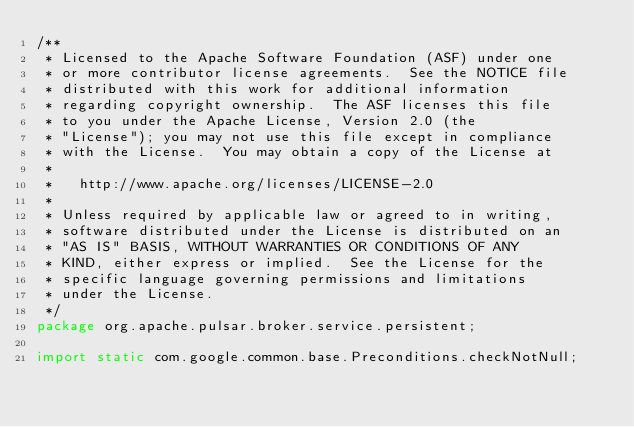Convert code to text. <code><loc_0><loc_0><loc_500><loc_500><_Java_>/**
 * Licensed to the Apache Software Foundation (ASF) under one
 * or more contributor license agreements.  See the NOTICE file
 * distributed with this work for additional information
 * regarding copyright ownership.  The ASF licenses this file
 * to you under the Apache License, Version 2.0 (the
 * "License"); you may not use this file except in compliance
 * with the License.  You may obtain a copy of the License at
 *
 *   http://www.apache.org/licenses/LICENSE-2.0
 *
 * Unless required by applicable law or agreed to in writing,
 * software distributed under the License is distributed on an
 * "AS IS" BASIS, WITHOUT WARRANTIES OR CONDITIONS OF ANY
 * KIND, either express or implied.  See the License for the
 * specific language governing permissions and limitations
 * under the License.
 */
package org.apache.pulsar.broker.service.persistent;

import static com.google.common.base.Preconditions.checkNotNull;</code> 